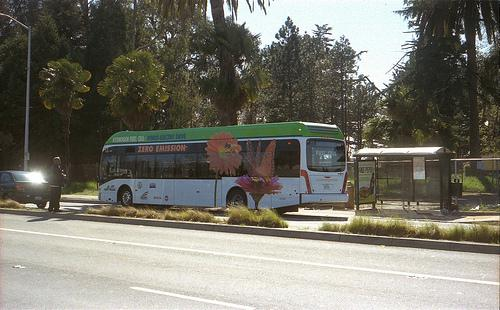Question: when was the picture taken?
Choices:
A. During the daytime.
B. At night.
C. Noon.
D. After school.
Answer with the letter. Answer: A Question: what is the color of the trees?
Choices:
A. Brown.
B. Gray.
C. White.
D. Green.
Answer with the letter. Answer: D Question: where is this taking place?
Choices:
A. In the park.
B. At the school.
C. In the street.
D. In a library.
Answer with the letter. Answer: C Question: where is the car?
Choices:
A. Near the bus.
B. On the street.
C. In the parking lot.
D. Behind the motorcycle.
Answer with the letter. Answer: A 